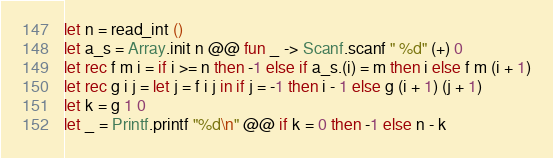<code> <loc_0><loc_0><loc_500><loc_500><_OCaml_>let n = read_int ()
let a_s = Array.init n @@ fun _ -> Scanf.scanf " %d" (+) 0
let rec f m i = if i >= n then -1 else if a_s.(i) = m then i else f m (i + 1)
let rec g i j = let j = f i j in if j = -1 then i - 1 else g (i + 1) (j + 1)
let k = g 1 0
let _ = Printf.printf "%d\n" @@ if k = 0 then -1 else n - k</code> 